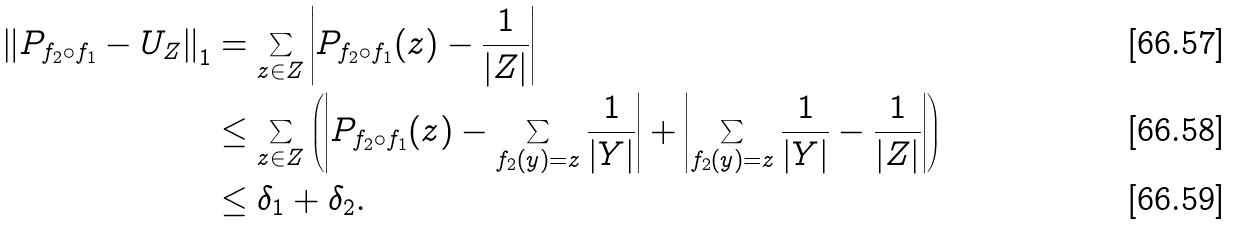<formula> <loc_0><loc_0><loc_500><loc_500>\left \| P _ { f _ { 2 } \circ f _ { 1 } } - U _ { Z } \right \| _ { 1 } & = \sum _ { z \in Z } \left | P _ { f _ { 2 } \circ f _ { 1 } } ( z ) - \frac { 1 } { | Z | } \right | \\ & \leq \sum _ { z \in Z } \left ( \left | P _ { f _ { 2 } \circ f _ { 1 } } ( z ) - \sum _ { f _ { 2 } ( y ) = z } \frac { 1 } { | Y | } \right | + \left | \sum _ { f _ { 2 } ( y ) = z } \frac { 1 } { | Y | } - \frac { 1 } { | Z | } \right | \right ) \\ & \leq \delta _ { 1 } + \delta _ { 2 } .</formula> 